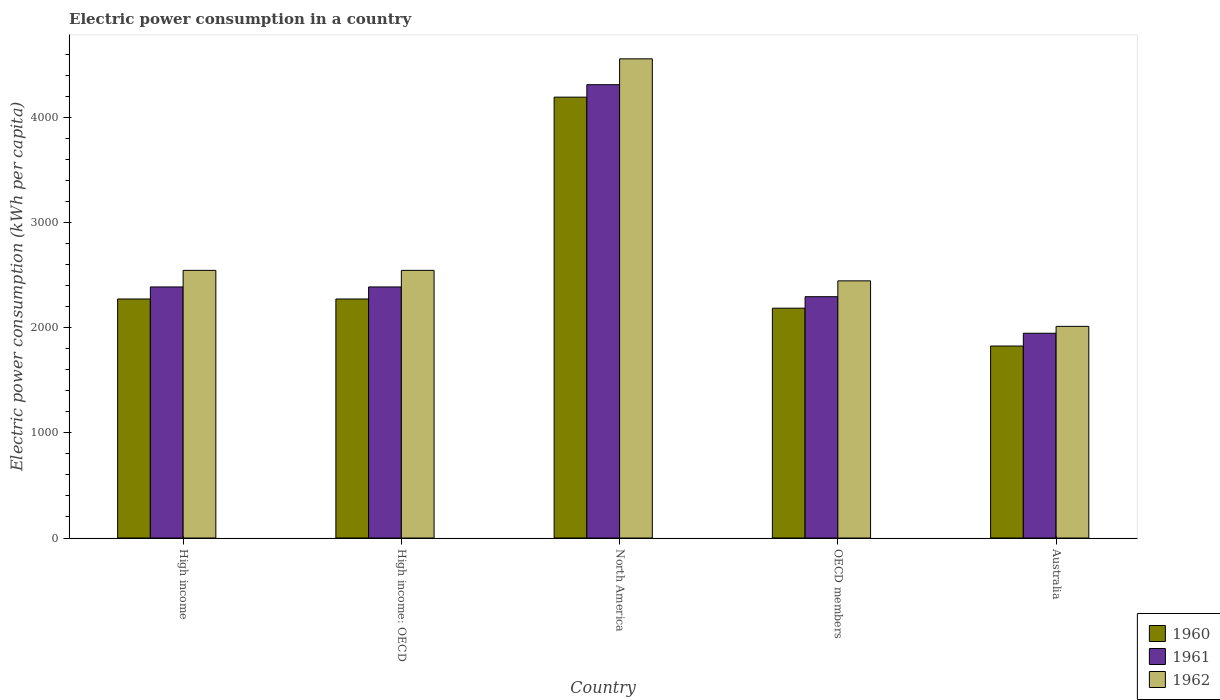How many groups of bars are there?
Your answer should be compact. 5. What is the label of the 2nd group of bars from the left?
Your response must be concise. High income: OECD. What is the electric power consumption in in 1960 in Australia?
Your answer should be compact. 1825.63. Across all countries, what is the maximum electric power consumption in in 1960?
Ensure brevity in your answer.  4192.36. Across all countries, what is the minimum electric power consumption in in 1961?
Offer a terse response. 1947.15. In which country was the electric power consumption in in 1962 maximum?
Your response must be concise. North America. In which country was the electric power consumption in in 1962 minimum?
Keep it short and to the point. Australia. What is the total electric power consumption in in 1961 in the graph?
Ensure brevity in your answer.  1.33e+04. What is the difference between the electric power consumption in in 1961 in High income and that in High income: OECD?
Keep it short and to the point. 0. What is the difference between the electric power consumption in in 1962 in North America and the electric power consumption in in 1961 in High income: OECD?
Offer a terse response. 2169.27. What is the average electric power consumption in in 1962 per country?
Your response must be concise. 2821.08. What is the difference between the electric power consumption in of/in 1960 and electric power consumption in of/in 1962 in Australia?
Keep it short and to the point. -187.03. What is the ratio of the electric power consumption in in 1962 in Australia to that in North America?
Offer a terse response. 0.44. Is the electric power consumption in in 1960 in Australia less than that in OECD members?
Ensure brevity in your answer.  Yes. What is the difference between the highest and the second highest electric power consumption in in 1961?
Your answer should be very brief. -1923.4. What is the difference between the highest and the lowest electric power consumption in in 1962?
Provide a short and direct response. 2544.12. In how many countries, is the electric power consumption in in 1960 greater than the average electric power consumption in in 1960 taken over all countries?
Ensure brevity in your answer.  1. Is the sum of the electric power consumption in in 1962 in High income: OECD and North America greater than the maximum electric power consumption in in 1961 across all countries?
Your response must be concise. Yes. What does the 3rd bar from the left in High income represents?
Ensure brevity in your answer.  1962. Is it the case that in every country, the sum of the electric power consumption in in 1960 and electric power consumption in in 1962 is greater than the electric power consumption in in 1961?
Your answer should be very brief. Yes. Are all the bars in the graph horizontal?
Give a very brief answer. No. How many countries are there in the graph?
Your answer should be compact. 5. Does the graph contain any zero values?
Provide a short and direct response. No. Does the graph contain grids?
Your response must be concise. No. Where does the legend appear in the graph?
Give a very brief answer. Bottom right. How many legend labels are there?
Ensure brevity in your answer.  3. What is the title of the graph?
Your answer should be very brief. Electric power consumption in a country. What is the label or title of the Y-axis?
Keep it short and to the point. Electric power consumption (kWh per capita). What is the Electric power consumption (kWh per capita) of 1960 in High income?
Ensure brevity in your answer.  2272.98. What is the Electric power consumption (kWh per capita) of 1961 in High income?
Provide a short and direct response. 2387.51. What is the Electric power consumption (kWh per capita) in 1962 in High income?
Provide a succinct answer. 2545.23. What is the Electric power consumption (kWh per capita) of 1960 in High income: OECD?
Your answer should be compact. 2272.98. What is the Electric power consumption (kWh per capita) in 1961 in High income: OECD?
Give a very brief answer. 2387.51. What is the Electric power consumption (kWh per capita) of 1962 in High income: OECD?
Give a very brief answer. 2545.23. What is the Electric power consumption (kWh per capita) of 1960 in North America?
Give a very brief answer. 4192.36. What is the Electric power consumption (kWh per capita) of 1961 in North America?
Your answer should be very brief. 4310.91. What is the Electric power consumption (kWh per capita) in 1962 in North America?
Your response must be concise. 4556.78. What is the Electric power consumption (kWh per capita) of 1960 in OECD members?
Provide a short and direct response. 2185.53. What is the Electric power consumption (kWh per capita) of 1961 in OECD members?
Offer a terse response. 2294.73. What is the Electric power consumption (kWh per capita) in 1962 in OECD members?
Your answer should be very brief. 2445.52. What is the Electric power consumption (kWh per capita) in 1960 in Australia?
Your answer should be compact. 1825.63. What is the Electric power consumption (kWh per capita) in 1961 in Australia?
Give a very brief answer. 1947.15. What is the Electric power consumption (kWh per capita) of 1962 in Australia?
Make the answer very short. 2012.66. Across all countries, what is the maximum Electric power consumption (kWh per capita) of 1960?
Your answer should be very brief. 4192.36. Across all countries, what is the maximum Electric power consumption (kWh per capita) in 1961?
Offer a terse response. 4310.91. Across all countries, what is the maximum Electric power consumption (kWh per capita) in 1962?
Your response must be concise. 4556.78. Across all countries, what is the minimum Electric power consumption (kWh per capita) in 1960?
Your response must be concise. 1825.63. Across all countries, what is the minimum Electric power consumption (kWh per capita) in 1961?
Make the answer very short. 1947.15. Across all countries, what is the minimum Electric power consumption (kWh per capita) of 1962?
Make the answer very short. 2012.66. What is the total Electric power consumption (kWh per capita) in 1960 in the graph?
Keep it short and to the point. 1.27e+04. What is the total Electric power consumption (kWh per capita) in 1961 in the graph?
Your answer should be very brief. 1.33e+04. What is the total Electric power consumption (kWh per capita) of 1962 in the graph?
Offer a terse response. 1.41e+04. What is the difference between the Electric power consumption (kWh per capita) of 1960 in High income and that in High income: OECD?
Provide a short and direct response. 0. What is the difference between the Electric power consumption (kWh per capita) in 1962 in High income and that in High income: OECD?
Ensure brevity in your answer.  0. What is the difference between the Electric power consumption (kWh per capita) in 1960 in High income and that in North America?
Your response must be concise. -1919.38. What is the difference between the Electric power consumption (kWh per capita) in 1961 in High income and that in North America?
Offer a very short reply. -1923.4. What is the difference between the Electric power consumption (kWh per capita) in 1962 in High income and that in North America?
Ensure brevity in your answer.  -2011.55. What is the difference between the Electric power consumption (kWh per capita) in 1960 in High income and that in OECD members?
Your answer should be very brief. 87.44. What is the difference between the Electric power consumption (kWh per capita) in 1961 in High income and that in OECD members?
Offer a terse response. 92.77. What is the difference between the Electric power consumption (kWh per capita) in 1962 in High income and that in OECD members?
Offer a terse response. 99.71. What is the difference between the Electric power consumption (kWh per capita) in 1960 in High income and that in Australia?
Offer a terse response. 447.35. What is the difference between the Electric power consumption (kWh per capita) in 1961 in High income and that in Australia?
Provide a succinct answer. 440.35. What is the difference between the Electric power consumption (kWh per capita) in 1962 in High income and that in Australia?
Offer a very short reply. 532.57. What is the difference between the Electric power consumption (kWh per capita) in 1960 in High income: OECD and that in North America?
Keep it short and to the point. -1919.38. What is the difference between the Electric power consumption (kWh per capita) in 1961 in High income: OECD and that in North America?
Your answer should be very brief. -1923.4. What is the difference between the Electric power consumption (kWh per capita) of 1962 in High income: OECD and that in North America?
Offer a terse response. -2011.55. What is the difference between the Electric power consumption (kWh per capita) of 1960 in High income: OECD and that in OECD members?
Your answer should be very brief. 87.44. What is the difference between the Electric power consumption (kWh per capita) of 1961 in High income: OECD and that in OECD members?
Provide a short and direct response. 92.77. What is the difference between the Electric power consumption (kWh per capita) in 1962 in High income: OECD and that in OECD members?
Provide a short and direct response. 99.71. What is the difference between the Electric power consumption (kWh per capita) in 1960 in High income: OECD and that in Australia?
Offer a very short reply. 447.35. What is the difference between the Electric power consumption (kWh per capita) in 1961 in High income: OECD and that in Australia?
Make the answer very short. 440.35. What is the difference between the Electric power consumption (kWh per capita) in 1962 in High income: OECD and that in Australia?
Your answer should be very brief. 532.57. What is the difference between the Electric power consumption (kWh per capita) of 1960 in North America and that in OECD members?
Provide a short and direct response. 2006.82. What is the difference between the Electric power consumption (kWh per capita) in 1961 in North America and that in OECD members?
Keep it short and to the point. 2016.17. What is the difference between the Electric power consumption (kWh per capita) of 1962 in North America and that in OECD members?
Ensure brevity in your answer.  2111.25. What is the difference between the Electric power consumption (kWh per capita) in 1960 in North America and that in Australia?
Offer a terse response. 2366.73. What is the difference between the Electric power consumption (kWh per capita) of 1961 in North America and that in Australia?
Your answer should be very brief. 2363.75. What is the difference between the Electric power consumption (kWh per capita) of 1962 in North America and that in Australia?
Your answer should be compact. 2544.12. What is the difference between the Electric power consumption (kWh per capita) of 1960 in OECD members and that in Australia?
Your answer should be very brief. 359.91. What is the difference between the Electric power consumption (kWh per capita) of 1961 in OECD members and that in Australia?
Offer a terse response. 347.58. What is the difference between the Electric power consumption (kWh per capita) in 1962 in OECD members and that in Australia?
Provide a short and direct response. 432.86. What is the difference between the Electric power consumption (kWh per capita) of 1960 in High income and the Electric power consumption (kWh per capita) of 1961 in High income: OECD?
Keep it short and to the point. -114.53. What is the difference between the Electric power consumption (kWh per capita) in 1960 in High income and the Electric power consumption (kWh per capita) in 1962 in High income: OECD?
Provide a short and direct response. -272.26. What is the difference between the Electric power consumption (kWh per capita) of 1961 in High income and the Electric power consumption (kWh per capita) of 1962 in High income: OECD?
Your answer should be very brief. -157.73. What is the difference between the Electric power consumption (kWh per capita) of 1960 in High income and the Electric power consumption (kWh per capita) of 1961 in North America?
Give a very brief answer. -2037.93. What is the difference between the Electric power consumption (kWh per capita) of 1960 in High income and the Electric power consumption (kWh per capita) of 1962 in North America?
Keep it short and to the point. -2283.8. What is the difference between the Electric power consumption (kWh per capita) in 1961 in High income and the Electric power consumption (kWh per capita) in 1962 in North America?
Provide a succinct answer. -2169.27. What is the difference between the Electric power consumption (kWh per capita) in 1960 in High income and the Electric power consumption (kWh per capita) in 1961 in OECD members?
Your response must be concise. -21.76. What is the difference between the Electric power consumption (kWh per capita) in 1960 in High income and the Electric power consumption (kWh per capita) in 1962 in OECD members?
Your response must be concise. -172.55. What is the difference between the Electric power consumption (kWh per capita) of 1961 in High income and the Electric power consumption (kWh per capita) of 1962 in OECD members?
Your answer should be compact. -58.02. What is the difference between the Electric power consumption (kWh per capita) in 1960 in High income and the Electric power consumption (kWh per capita) in 1961 in Australia?
Provide a short and direct response. 325.82. What is the difference between the Electric power consumption (kWh per capita) of 1960 in High income and the Electric power consumption (kWh per capita) of 1962 in Australia?
Give a very brief answer. 260.32. What is the difference between the Electric power consumption (kWh per capita) in 1961 in High income and the Electric power consumption (kWh per capita) in 1962 in Australia?
Provide a short and direct response. 374.84. What is the difference between the Electric power consumption (kWh per capita) of 1960 in High income: OECD and the Electric power consumption (kWh per capita) of 1961 in North America?
Give a very brief answer. -2037.93. What is the difference between the Electric power consumption (kWh per capita) of 1960 in High income: OECD and the Electric power consumption (kWh per capita) of 1962 in North America?
Provide a succinct answer. -2283.8. What is the difference between the Electric power consumption (kWh per capita) in 1961 in High income: OECD and the Electric power consumption (kWh per capita) in 1962 in North America?
Keep it short and to the point. -2169.27. What is the difference between the Electric power consumption (kWh per capita) in 1960 in High income: OECD and the Electric power consumption (kWh per capita) in 1961 in OECD members?
Provide a succinct answer. -21.76. What is the difference between the Electric power consumption (kWh per capita) of 1960 in High income: OECD and the Electric power consumption (kWh per capita) of 1962 in OECD members?
Your answer should be very brief. -172.55. What is the difference between the Electric power consumption (kWh per capita) in 1961 in High income: OECD and the Electric power consumption (kWh per capita) in 1962 in OECD members?
Provide a short and direct response. -58.02. What is the difference between the Electric power consumption (kWh per capita) in 1960 in High income: OECD and the Electric power consumption (kWh per capita) in 1961 in Australia?
Ensure brevity in your answer.  325.82. What is the difference between the Electric power consumption (kWh per capita) in 1960 in High income: OECD and the Electric power consumption (kWh per capita) in 1962 in Australia?
Make the answer very short. 260.32. What is the difference between the Electric power consumption (kWh per capita) in 1961 in High income: OECD and the Electric power consumption (kWh per capita) in 1962 in Australia?
Ensure brevity in your answer.  374.84. What is the difference between the Electric power consumption (kWh per capita) in 1960 in North America and the Electric power consumption (kWh per capita) in 1961 in OECD members?
Keep it short and to the point. 1897.62. What is the difference between the Electric power consumption (kWh per capita) of 1960 in North America and the Electric power consumption (kWh per capita) of 1962 in OECD members?
Provide a succinct answer. 1746.83. What is the difference between the Electric power consumption (kWh per capita) in 1961 in North America and the Electric power consumption (kWh per capita) in 1962 in OECD members?
Your answer should be very brief. 1865.38. What is the difference between the Electric power consumption (kWh per capita) of 1960 in North America and the Electric power consumption (kWh per capita) of 1961 in Australia?
Your answer should be very brief. 2245.2. What is the difference between the Electric power consumption (kWh per capita) of 1960 in North America and the Electric power consumption (kWh per capita) of 1962 in Australia?
Make the answer very short. 2179.7. What is the difference between the Electric power consumption (kWh per capita) of 1961 in North America and the Electric power consumption (kWh per capita) of 1962 in Australia?
Ensure brevity in your answer.  2298.24. What is the difference between the Electric power consumption (kWh per capita) in 1960 in OECD members and the Electric power consumption (kWh per capita) in 1961 in Australia?
Keep it short and to the point. 238.38. What is the difference between the Electric power consumption (kWh per capita) in 1960 in OECD members and the Electric power consumption (kWh per capita) in 1962 in Australia?
Keep it short and to the point. 172.87. What is the difference between the Electric power consumption (kWh per capita) of 1961 in OECD members and the Electric power consumption (kWh per capita) of 1962 in Australia?
Your response must be concise. 282.07. What is the average Electric power consumption (kWh per capita) of 1960 per country?
Offer a terse response. 2549.89. What is the average Electric power consumption (kWh per capita) in 1961 per country?
Your answer should be very brief. 2665.56. What is the average Electric power consumption (kWh per capita) of 1962 per country?
Ensure brevity in your answer.  2821.08. What is the difference between the Electric power consumption (kWh per capita) of 1960 and Electric power consumption (kWh per capita) of 1961 in High income?
Provide a succinct answer. -114.53. What is the difference between the Electric power consumption (kWh per capita) of 1960 and Electric power consumption (kWh per capita) of 1962 in High income?
Give a very brief answer. -272.26. What is the difference between the Electric power consumption (kWh per capita) of 1961 and Electric power consumption (kWh per capita) of 1962 in High income?
Provide a succinct answer. -157.73. What is the difference between the Electric power consumption (kWh per capita) in 1960 and Electric power consumption (kWh per capita) in 1961 in High income: OECD?
Provide a succinct answer. -114.53. What is the difference between the Electric power consumption (kWh per capita) in 1960 and Electric power consumption (kWh per capita) in 1962 in High income: OECD?
Your answer should be compact. -272.26. What is the difference between the Electric power consumption (kWh per capita) of 1961 and Electric power consumption (kWh per capita) of 1962 in High income: OECD?
Provide a succinct answer. -157.73. What is the difference between the Electric power consumption (kWh per capita) of 1960 and Electric power consumption (kWh per capita) of 1961 in North America?
Offer a very short reply. -118.55. What is the difference between the Electric power consumption (kWh per capita) in 1960 and Electric power consumption (kWh per capita) in 1962 in North America?
Provide a short and direct response. -364.42. What is the difference between the Electric power consumption (kWh per capita) of 1961 and Electric power consumption (kWh per capita) of 1962 in North America?
Offer a very short reply. -245.87. What is the difference between the Electric power consumption (kWh per capita) of 1960 and Electric power consumption (kWh per capita) of 1961 in OECD members?
Offer a very short reply. -109.2. What is the difference between the Electric power consumption (kWh per capita) of 1960 and Electric power consumption (kWh per capita) of 1962 in OECD members?
Give a very brief answer. -259.99. What is the difference between the Electric power consumption (kWh per capita) in 1961 and Electric power consumption (kWh per capita) in 1962 in OECD members?
Your answer should be compact. -150.79. What is the difference between the Electric power consumption (kWh per capita) of 1960 and Electric power consumption (kWh per capita) of 1961 in Australia?
Give a very brief answer. -121.53. What is the difference between the Electric power consumption (kWh per capita) of 1960 and Electric power consumption (kWh per capita) of 1962 in Australia?
Your response must be concise. -187.03. What is the difference between the Electric power consumption (kWh per capita) in 1961 and Electric power consumption (kWh per capita) in 1962 in Australia?
Provide a succinct answer. -65.51. What is the ratio of the Electric power consumption (kWh per capita) of 1960 in High income to that in North America?
Your answer should be very brief. 0.54. What is the ratio of the Electric power consumption (kWh per capita) in 1961 in High income to that in North America?
Provide a succinct answer. 0.55. What is the ratio of the Electric power consumption (kWh per capita) of 1962 in High income to that in North America?
Offer a terse response. 0.56. What is the ratio of the Electric power consumption (kWh per capita) of 1960 in High income to that in OECD members?
Your answer should be very brief. 1.04. What is the ratio of the Electric power consumption (kWh per capita) of 1961 in High income to that in OECD members?
Make the answer very short. 1.04. What is the ratio of the Electric power consumption (kWh per capita) in 1962 in High income to that in OECD members?
Your answer should be compact. 1.04. What is the ratio of the Electric power consumption (kWh per capita) in 1960 in High income to that in Australia?
Your response must be concise. 1.25. What is the ratio of the Electric power consumption (kWh per capita) in 1961 in High income to that in Australia?
Keep it short and to the point. 1.23. What is the ratio of the Electric power consumption (kWh per capita) in 1962 in High income to that in Australia?
Keep it short and to the point. 1.26. What is the ratio of the Electric power consumption (kWh per capita) of 1960 in High income: OECD to that in North America?
Your response must be concise. 0.54. What is the ratio of the Electric power consumption (kWh per capita) of 1961 in High income: OECD to that in North America?
Provide a succinct answer. 0.55. What is the ratio of the Electric power consumption (kWh per capita) in 1962 in High income: OECD to that in North America?
Give a very brief answer. 0.56. What is the ratio of the Electric power consumption (kWh per capita) in 1961 in High income: OECD to that in OECD members?
Provide a short and direct response. 1.04. What is the ratio of the Electric power consumption (kWh per capita) in 1962 in High income: OECD to that in OECD members?
Give a very brief answer. 1.04. What is the ratio of the Electric power consumption (kWh per capita) of 1960 in High income: OECD to that in Australia?
Keep it short and to the point. 1.25. What is the ratio of the Electric power consumption (kWh per capita) of 1961 in High income: OECD to that in Australia?
Provide a short and direct response. 1.23. What is the ratio of the Electric power consumption (kWh per capita) of 1962 in High income: OECD to that in Australia?
Keep it short and to the point. 1.26. What is the ratio of the Electric power consumption (kWh per capita) in 1960 in North America to that in OECD members?
Provide a succinct answer. 1.92. What is the ratio of the Electric power consumption (kWh per capita) in 1961 in North America to that in OECD members?
Provide a short and direct response. 1.88. What is the ratio of the Electric power consumption (kWh per capita) in 1962 in North America to that in OECD members?
Provide a succinct answer. 1.86. What is the ratio of the Electric power consumption (kWh per capita) in 1960 in North America to that in Australia?
Your answer should be very brief. 2.3. What is the ratio of the Electric power consumption (kWh per capita) of 1961 in North America to that in Australia?
Give a very brief answer. 2.21. What is the ratio of the Electric power consumption (kWh per capita) in 1962 in North America to that in Australia?
Provide a short and direct response. 2.26. What is the ratio of the Electric power consumption (kWh per capita) of 1960 in OECD members to that in Australia?
Ensure brevity in your answer.  1.2. What is the ratio of the Electric power consumption (kWh per capita) of 1961 in OECD members to that in Australia?
Provide a short and direct response. 1.18. What is the ratio of the Electric power consumption (kWh per capita) of 1962 in OECD members to that in Australia?
Offer a very short reply. 1.22. What is the difference between the highest and the second highest Electric power consumption (kWh per capita) in 1960?
Offer a terse response. 1919.38. What is the difference between the highest and the second highest Electric power consumption (kWh per capita) in 1961?
Make the answer very short. 1923.4. What is the difference between the highest and the second highest Electric power consumption (kWh per capita) in 1962?
Provide a succinct answer. 2011.55. What is the difference between the highest and the lowest Electric power consumption (kWh per capita) of 1960?
Give a very brief answer. 2366.73. What is the difference between the highest and the lowest Electric power consumption (kWh per capita) in 1961?
Offer a terse response. 2363.75. What is the difference between the highest and the lowest Electric power consumption (kWh per capita) in 1962?
Give a very brief answer. 2544.12. 